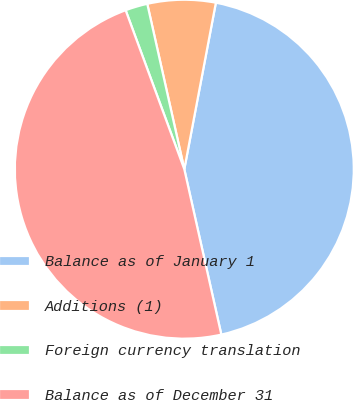Convert chart. <chart><loc_0><loc_0><loc_500><loc_500><pie_chart><fcel>Balance as of January 1<fcel>Additions (1)<fcel>Foreign currency translation<fcel>Balance as of December 31<nl><fcel>43.51%<fcel>6.49%<fcel>2.12%<fcel>47.88%<nl></chart> 